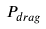<formula> <loc_0><loc_0><loc_500><loc_500>P _ { d r a g }</formula> 